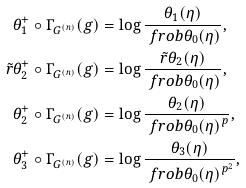Convert formula to latex. <formula><loc_0><loc_0><loc_500><loc_500>\theta ^ { + } _ { 1 } \circ \Gamma _ { G ^ { ( n ) } } ( g ) & = \log \frac { \theta _ { 1 } ( \eta ) } { \ f r o b { \theta _ { 0 } ( \eta ) } } , \\ \tilde { r } { \theta } ^ { + } _ { 2 } \circ \Gamma _ { G ^ { ( n ) } } ( g ) & = \log \frac { \tilde { r } { \theta } _ { 2 } ( \eta ) } { \ f r o b { \theta _ { 0 } ( \eta ) } } , \\ \theta ^ { + } _ { 2 } \circ \Gamma _ { G ^ { ( n ) } } ( g ) & = \log \frac { \theta _ { 2 } ( \eta ) } { \ f r o b { \theta _ { 0 } ( \eta ) } ^ { p } } , \\ \theta ^ { + } _ { 3 } \circ \Gamma _ { G ^ { ( n ) } } ( g ) & = \log \frac { \theta _ { 3 } ( \eta ) } { \ f r o b { \theta _ { 0 } ( \eta ) } ^ { p ^ { 2 } } } ,</formula> 